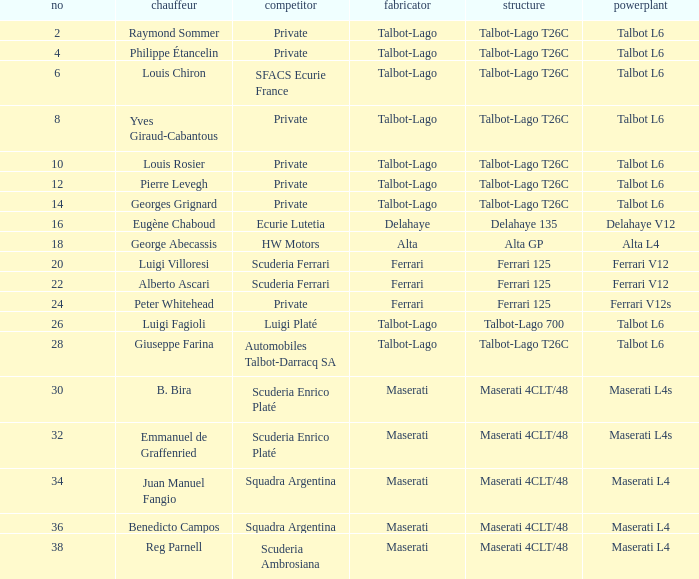Name the constructor for b. bira Maserati. 